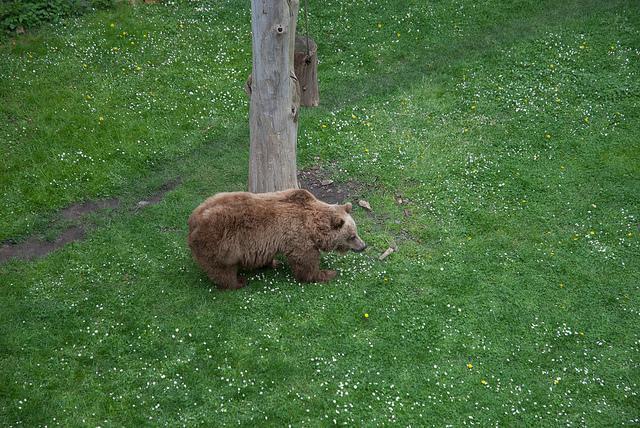How many bears are in the photo?
Give a very brief answer. 1. 